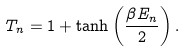Convert formula to latex. <formula><loc_0><loc_0><loc_500><loc_500>T _ { n } = 1 + \tanh \left ( \frac { \beta E _ { n } } { 2 } \right ) .</formula> 